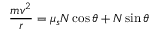<formula> <loc_0><loc_0><loc_500><loc_500>{ \frac { m v ^ { 2 } } { r } } = \mu _ { s } N \cos \theta + N \sin \theta</formula> 